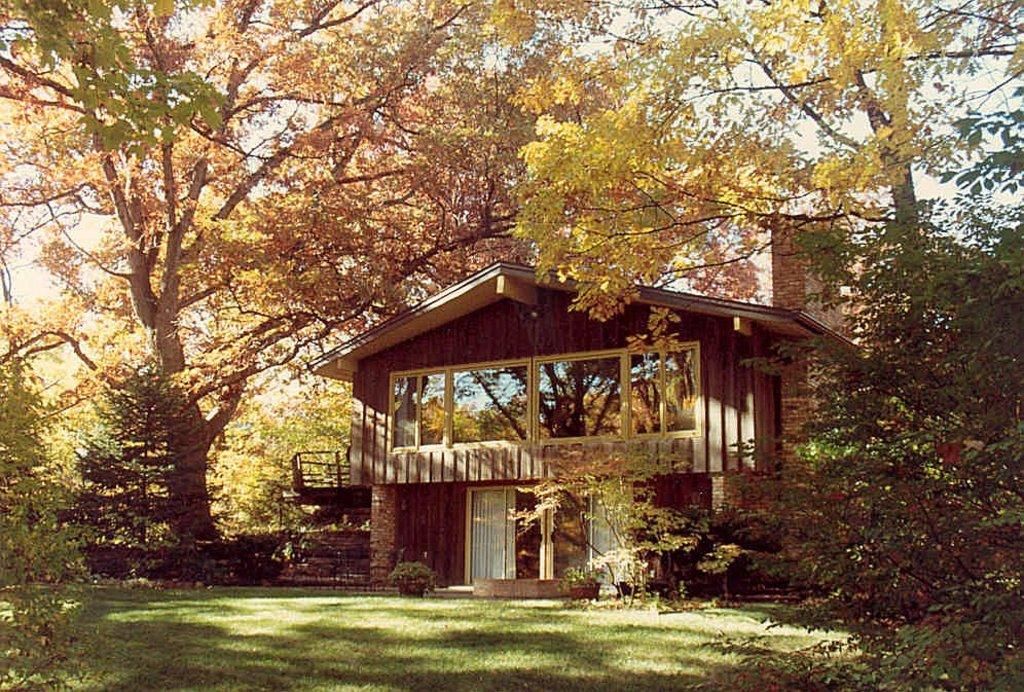What type of vegetation can be seen in the image? There is grass, plants, and trees in the image. What type of structure is visible in the image? There is a house in the image. What is visible at the top of the image? The sky is visible at the top of the image. Can you see a drum being played on the sidewalk in the image? There is no drum or sidewalk present in the image. What season is depicted in the image, given the presence of spring flowers? There is no mention of spring flowers or any specific season in the image; it only features grass, plants, trees, a house, and the sky. 